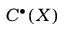<formula> <loc_0><loc_0><loc_500><loc_500>C ^ { \bullet } ( X )</formula> 